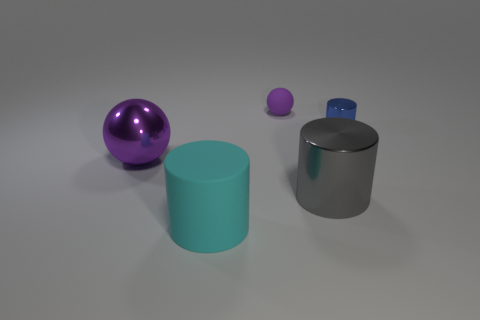Subtract all shiny cylinders. How many cylinders are left? 1 Add 1 large metallic things. How many objects exist? 6 Subtract all cylinders. How many objects are left? 2 Subtract all yellow cylinders. Subtract all yellow blocks. How many cylinders are left? 3 Subtract all big purple shiny balls. Subtract all small blue things. How many objects are left? 3 Add 5 gray cylinders. How many gray cylinders are left? 6 Add 1 large cyan matte things. How many large cyan matte things exist? 2 Subtract 0 brown cylinders. How many objects are left? 5 